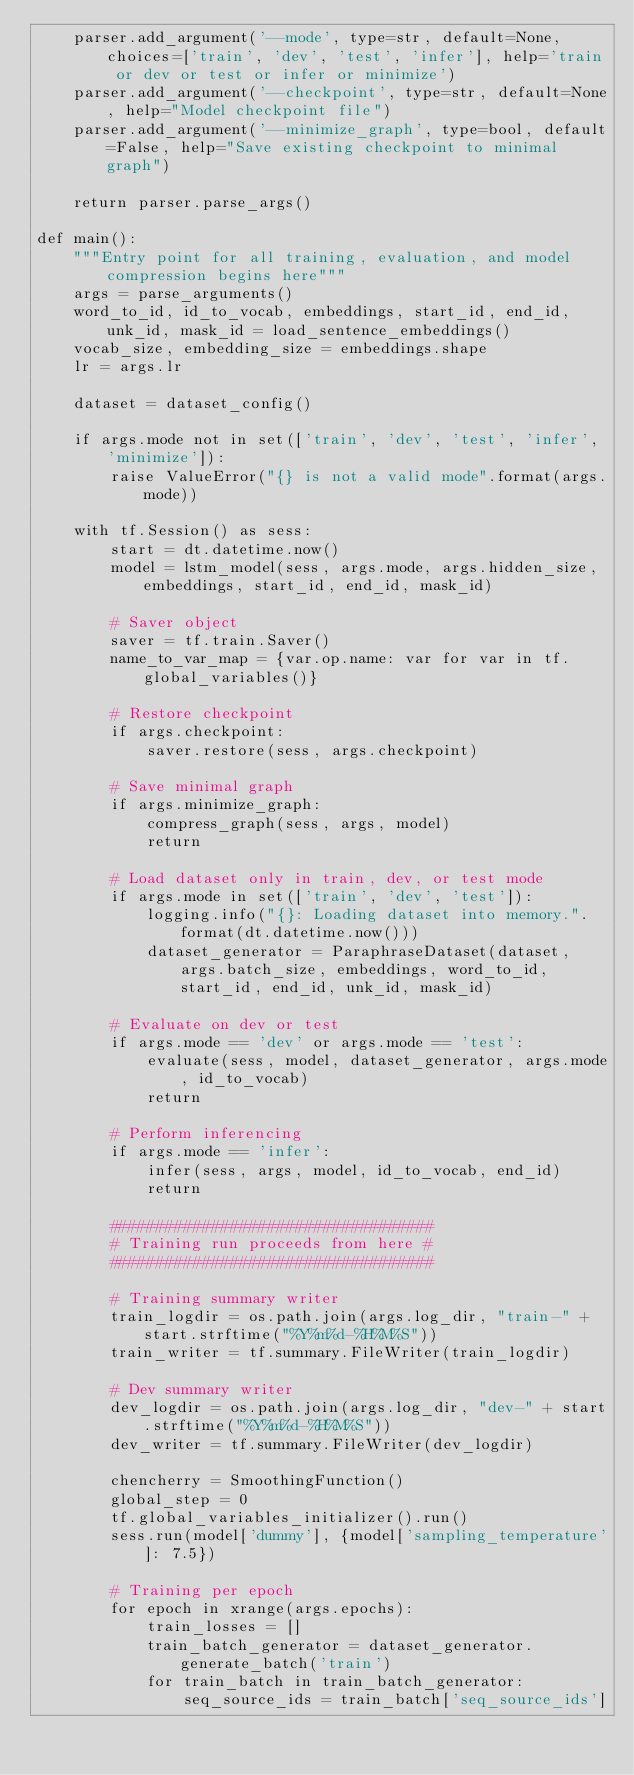Convert code to text. <code><loc_0><loc_0><loc_500><loc_500><_Python_>    parser.add_argument('--mode', type=str, default=None, choices=['train', 'dev', 'test', 'infer'], help='train or dev or test or infer or minimize')
    parser.add_argument('--checkpoint', type=str, default=None, help="Model checkpoint file")
    parser.add_argument('--minimize_graph', type=bool, default=False, help="Save existing checkpoint to minimal graph")

    return parser.parse_args()

def main():
    """Entry point for all training, evaluation, and model compression begins here"""
    args = parse_arguments()
    word_to_id, id_to_vocab, embeddings, start_id, end_id, unk_id, mask_id = load_sentence_embeddings()
    vocab_size, embedding_size = embeddings.shape
    lr = args.lr

    dataset = dataset_config()

    if args.mode not in set(['train', 'dev', 'test', 'infer', 'minimize']):
        raise ValueError("{} is not a valid mode".format(args.mode))

    with tf.Session() as sess:
        start = dt.datetime.now()
        model = lstm_model(sess, args.mode, args.hidden_size, embeddings, start_id, end_id, mask_id)

        # Saver object
        saver = tf.train.Saver()
        name_to_var_map = {var.op.name: var for var in tf.global_variables()}

        # Restore checkpoint
        if args.checkpoint:
            saver.restore(sess, args.checkpoint)

        # Save minimal graph
        if args.minimize_graph:
            compress_graph(sess, args, model)
            return

        # Load dataset only in train, dev, or test mode
        if args.mode in set(['train', 'dev', 'test']):
            logging.info("{}: Loading dataset into memory.".format(dt.datetime.now()))
            dataset_generator = ParaphraseDataset(dataset, args.batch_size, embeddings, word_to_id, start_id, end_id, unk_id, mask_id)

        # Evaluate on dev or test
        if args.mode == 'dev' or args.mode == 'test':
            evaluate(sess, model, dataset_generator, args.mode, id_to_vocab)
            return

        # Perform inferencing
        if args.mode == 'infer':
            infer(sess, args, model, id_to_vocab, end_id)
            return

        ###################################
        # Training run proceeds from here #
        ###################################

        # Training summary writer
        train_logdir = os.path.join(args.log_dir, "train-" + start.strftime("%Y%m%d-%H%M%S"))
        train_writer = tf.summary.FileWriter(train_logdir)

        # Dev summary writer
        dev_logdir = os.path.join(args.log_dir, "dev-" + start.strftime("%Y%m%d-%H%M%S"))
        dev_writer = tf.summary.FileWriter(dev_logdir)

        chencherry = SmoothingFunction()
        global_step = 0
        tf.global_variables_initializer().run()
        sess.run(model['dummy'], {model['sampling_temperature']: 7.5})

        # Training per epoch
        for epoch in xrange(args.epochs):
            train_losses = []
            train_batch_generator = dataset_generator.generate_batch('train')
            for train_batch in train_batch_generator:
                seq_source_ids = train_batch['seq_source_ids']</code> 